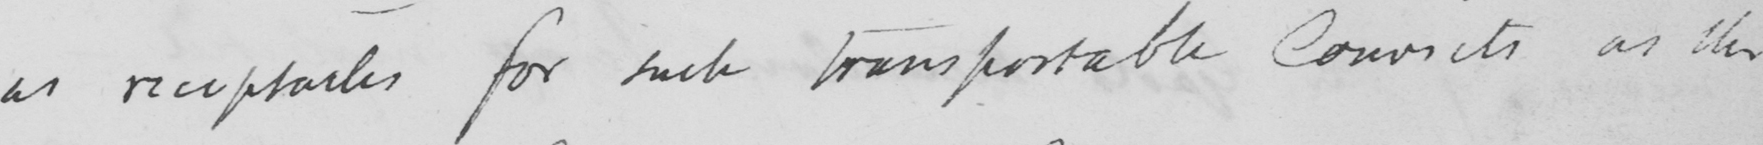Transcribe the text shown in this historical manuscript line. as receptacles for such transportable Convicts as the 